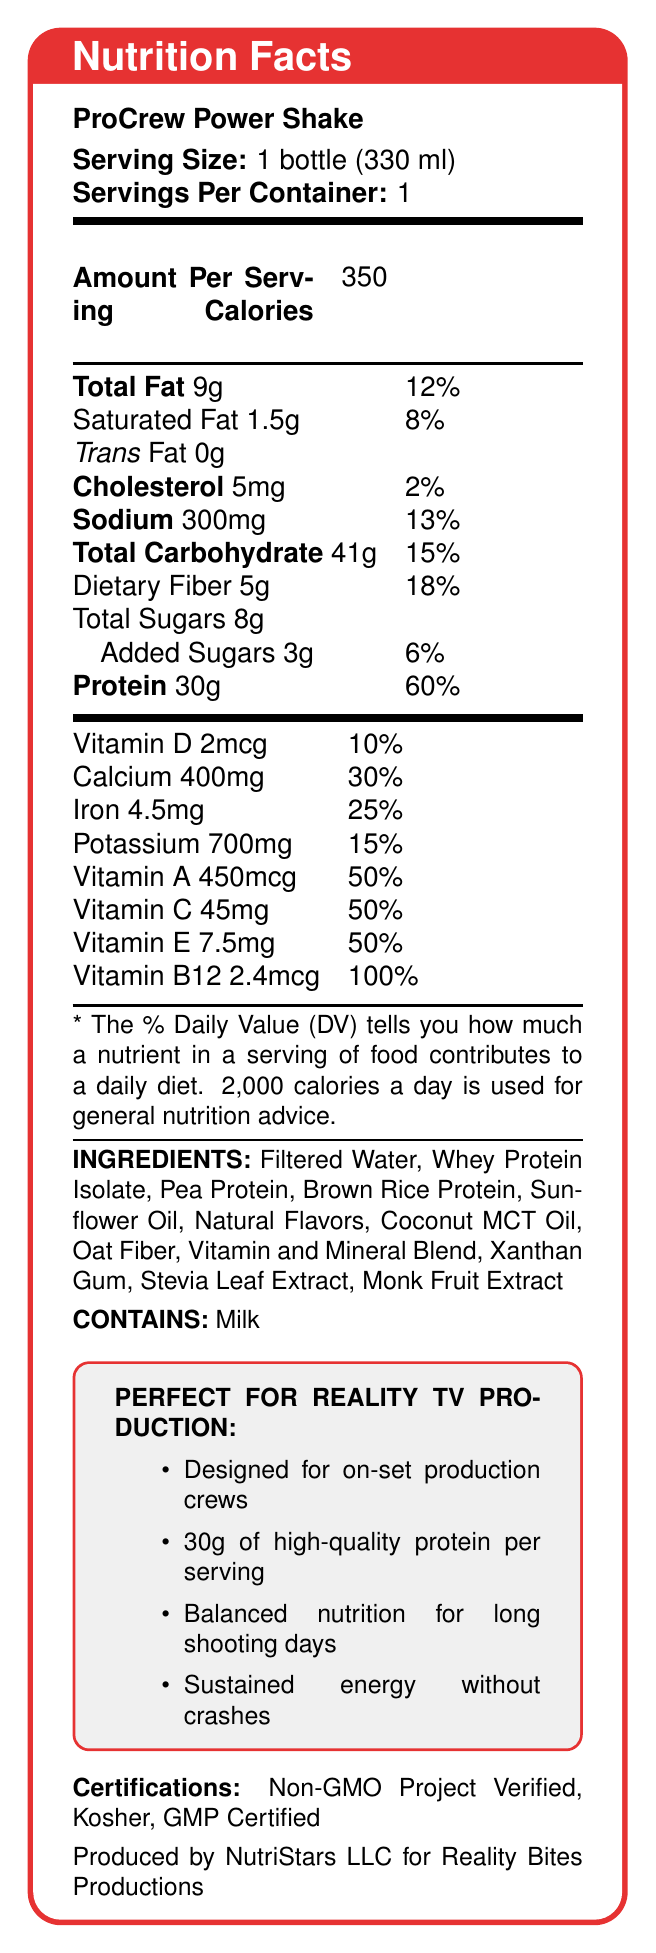what is the serving size of the ProCrew Power Shake? The serving size is clearly stated at the beginning of the document as 1 bottle (330 ml).
Answer: 1 bottle (330 ml) how many calories are in one serving of the ProCrew Power Shake? The document lists the amount of calories per serving as 350 under the section marked "Amount Per Serving."
Answer: 350 what percentage of the daily value for protein does one serving provide? The label specifies that one serving provides 30g of protein, which is 60% of the daily value.
Answer: 60% which vitamins each provide 50% of the daily value per serving? The document lists Vitamin A, Vitamin C, and Vitamin E each providing 50% of the daily value per serving.
Answer: Vitamin A, Vitamin C, and Vitamin E what are the total carbohydrates in one serving, and what is its daily value percentage? The label states that total carbohydrates per serving is 41g, which corresponds to 15% of the daily value.
Answer: 41g, 15% which ingredient in the ProCrew Power Shake is a potential allergen? A. Coconut MCT Oil B. Whey Protein Isolate C. Oat Fiber D. Xanthan Gum The allergen information section states that the product contains milk, derived from Whey Protein Isolate.
Answer: B. Whey Protein Isolate which of the following certifications does the ProCrew Power Shake hold? 
(i) Organic 
(ii) Non-GMO Project Verified 
(iii) Kosher 
(iv) GMP Certified 
Choose all that apply. The document lists the certifications as Non-GMO Project Verified, Kosher, and GMP Certified. Organic is not mentioned.
Answer: ii, iii, iv is there any trans fat in the ProCrew Power Shake? The label explicitly states that trans fat is 0g.
Answer: No does the ProCrew Power Shake provide sustained energy without crashes? This is mentioned under the marketing claims section of the document.
Answer: Yes summarize the information provided in the nutritional label. The document highlights the key nutritional facts, marketing claims, and certifies that support the product's aim to provide a balanced and energy-sustaining meal replacement for production crews.
Answer: The ProCrew Power Shake is a protein-packed meal replacement shake designed for on-set production crews, providing 30g of high-quality protein per serving. The nutritional facts indicate it offers balanced nutrition with a significant percentage of daily value for vitamins, minerals, and protein. It contains no trans fat and is certified by several quality and dietary standards. The product is designed to sustain energy for long production days. who manufactures the ProCrew Power Shake? The manufacturer information at the end of the document states that the product is produced by NutriStars LLC for Reality Bites Productions.
Answer: NutriStars LLC for Reality Bites Productions what is the shelf life of the ProCrew Power Shake? The storage instructions indicate that the shelf life is 12 months when unopened, and it should be refrigerated after opening.
Answer: 12 months unopened, refrigerate after opening does the ProCrew Power Shake contain added sugars? The label specifies that there are 3g of added sugars, which is 6% of the daily value.
Answer: Yes what ingredients, other than proteins, are included in the ProCrew Power Shake? The ingredients list includes these items in addition to the various protein sources.
Answer: Filtered Water, Sunflower Oil, Natural Flavors, Coconut MCT Oil, Oat Fiber, Vitamin and Mineral Blend, Xanthan Gum, Stevia Leaf Extract, Monk Fruit Extract is the ProCrew Power Shake suitable for vegans? The document states that the shake contains milk, but it doesn't indicate whether all ingredients and manufacturing processes are vegan-friendly.
Answer: Not enough information 